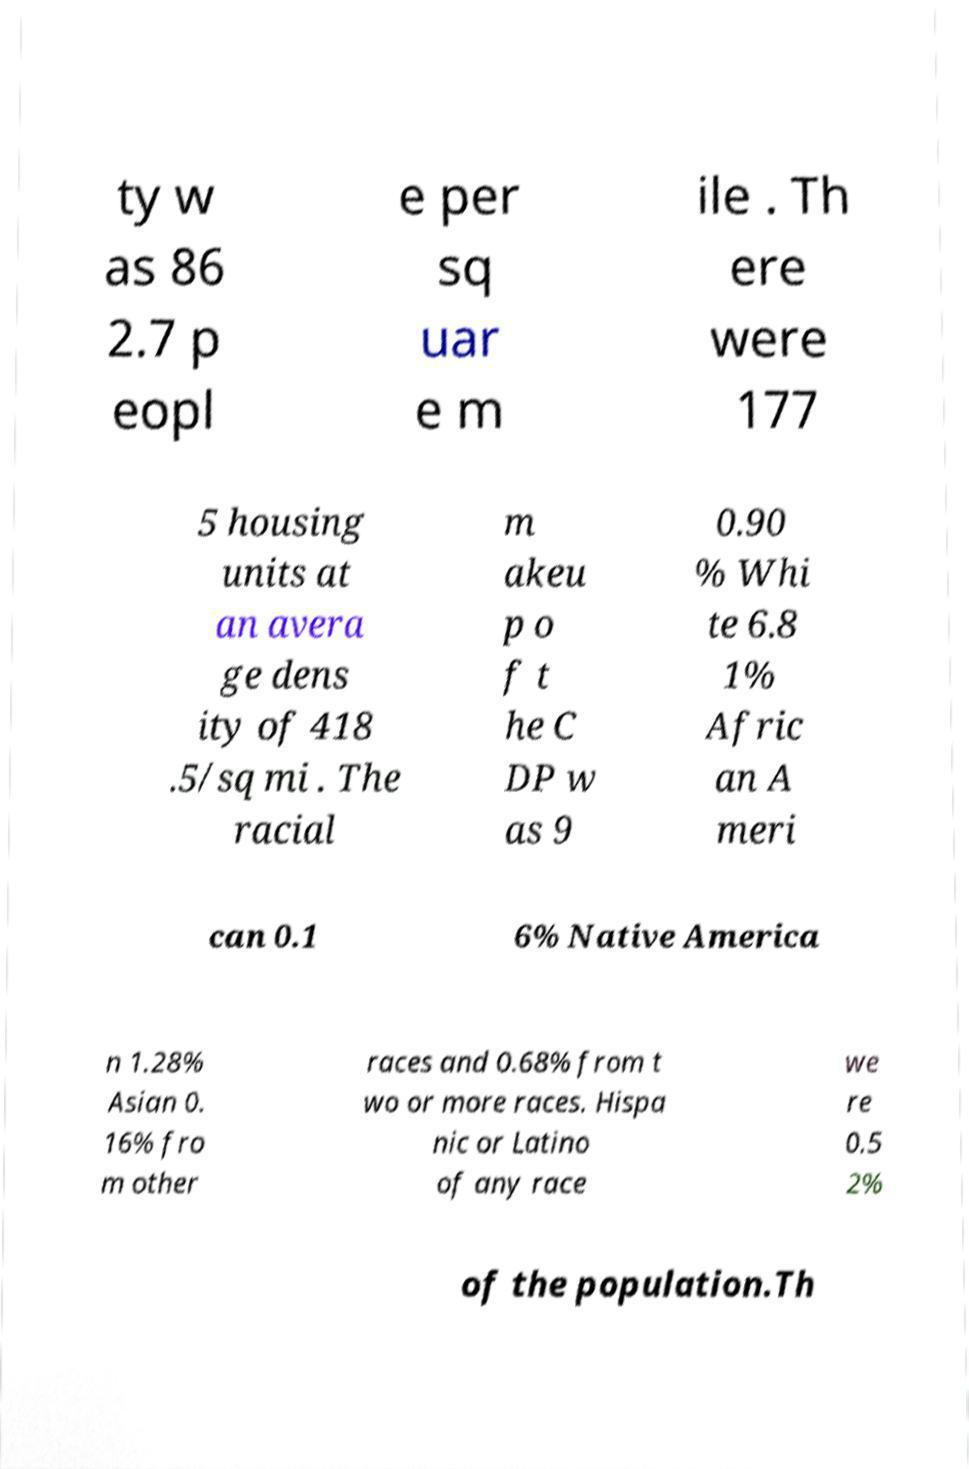What messages or text are displayed in this image? I need them in a readable, typed format. ty w as 86 2.7 p eopl e per sq uar e m ile . Th ere were 177 5 housing units at an avera ge dens ity of 418 .5/sq mi . The racial m akeu p o f t he C DP w as 9 0.90 % Whi te 6.8 1% Afric an A meri can 0.1 6% Native America n 1.28% Asian 0. 16% fro m other races and 0.68% from t wo or more races. Hispa nic or Latino of any race we re 0.5 2% of the population.Th 